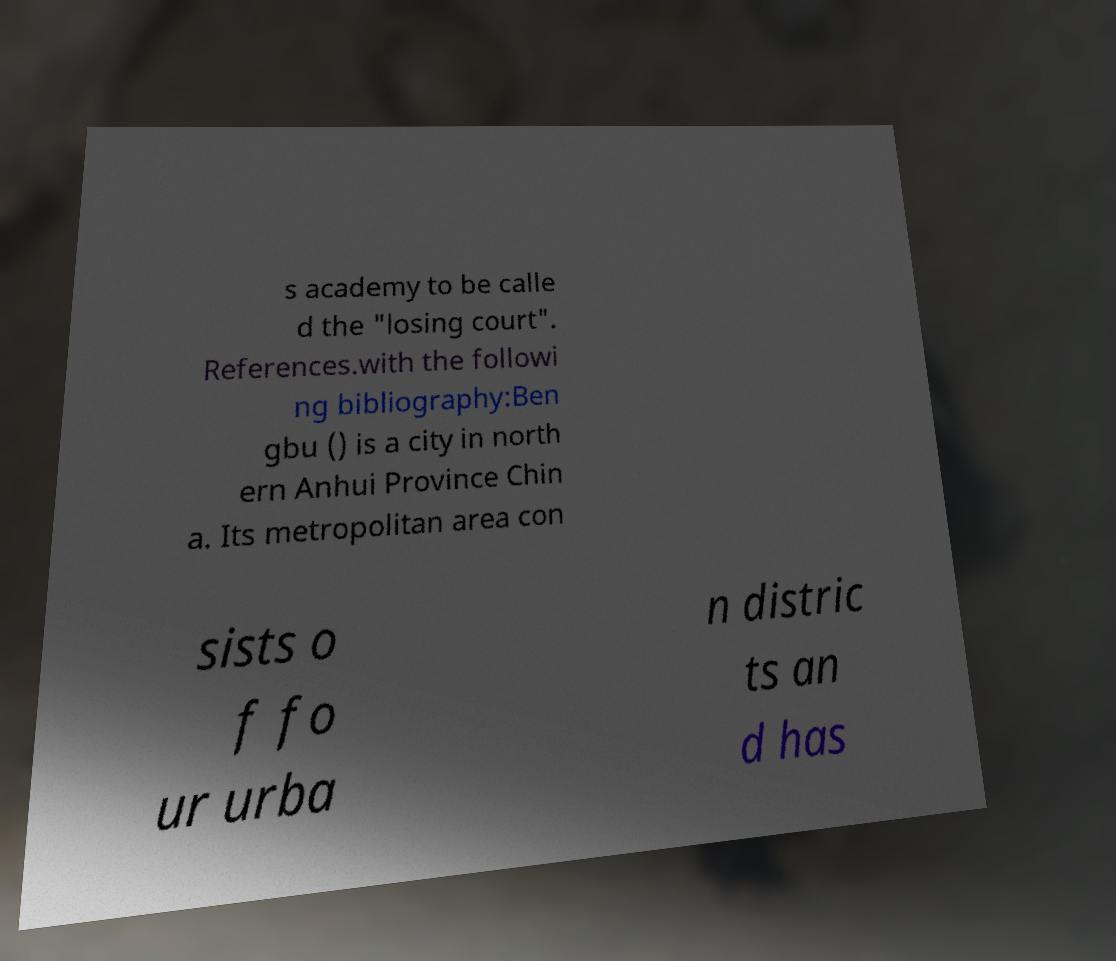Please read and relay the text visible in this image. What does it say? s academy to be calle d the "losing court". References.with the followi ng bibliography:Ben gbu () is a city in north ern Anhui Province Chin a. Its metropolitan area con sists o f fo ur urba n distric ts an d has 